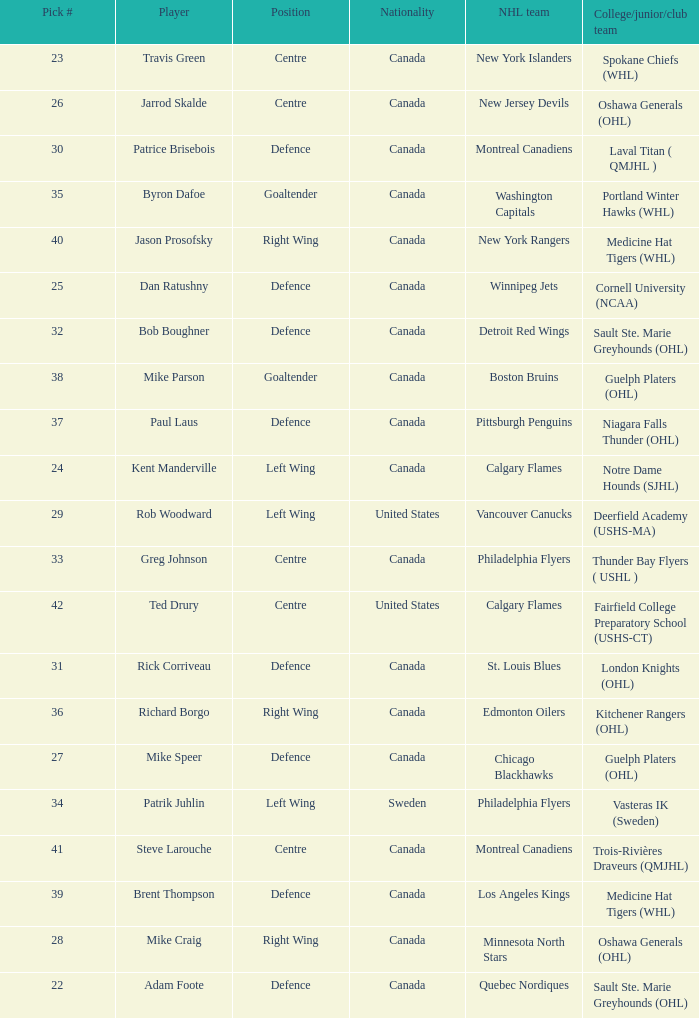What NHL team picked richard borgo? Edmonton Oilers. 